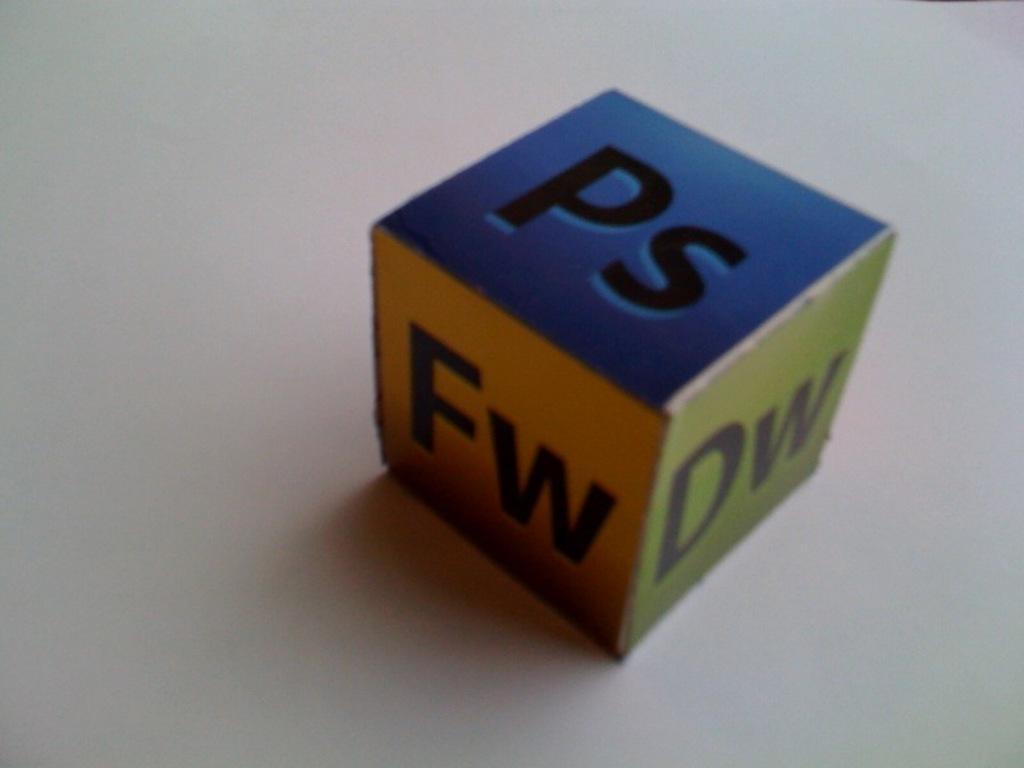In one or two sentences, can you explain what this image depicts? This is a zoomed in picture. In the center there is a colorful box placed on a white color object and we can see the text on the box. 